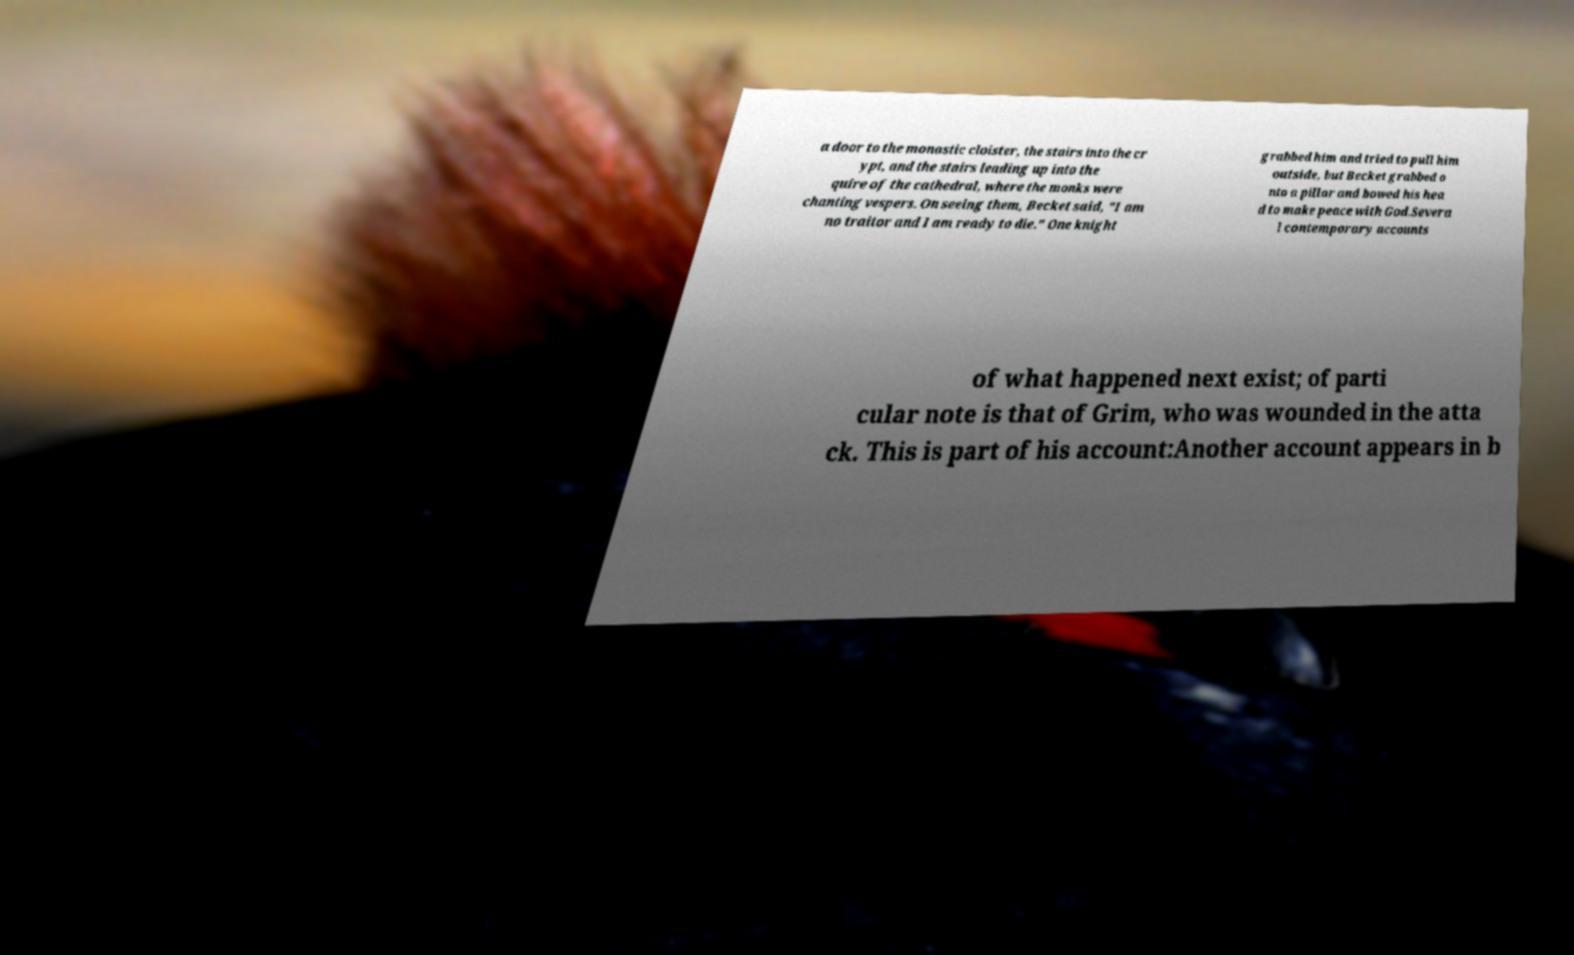What messages or text are displayed in this image? I need them in a readable, typed format. a door to the monastic cloister, the stairs into the cr ypt, and the stairs leading up into the quire of the cathedral, where the monks were chanting vespers. On seeing them, Becket said, "I am no traitor and I am ready to die." One knight grabbed him and tried to pull him outside, but Becket grabbed o nto a pillar and bowed his hea d to make peace with God.Severa l contemporary accounts of what happened next exist; of parti cular note is that of Grim, who was wounded in the atta ck. This is part of his account:Another account appears in b 